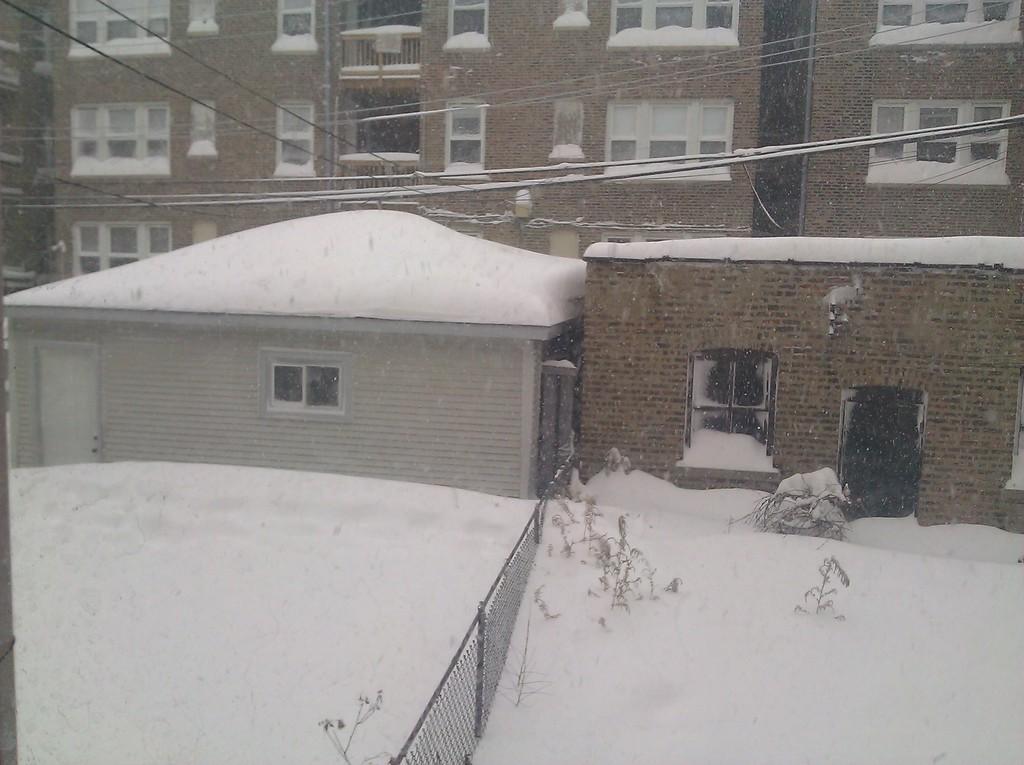Can you describe this image briefly? On the left side, there are plants and a fence on a snowy surface. In the background, there are cables and there are buildings which are having windows. 